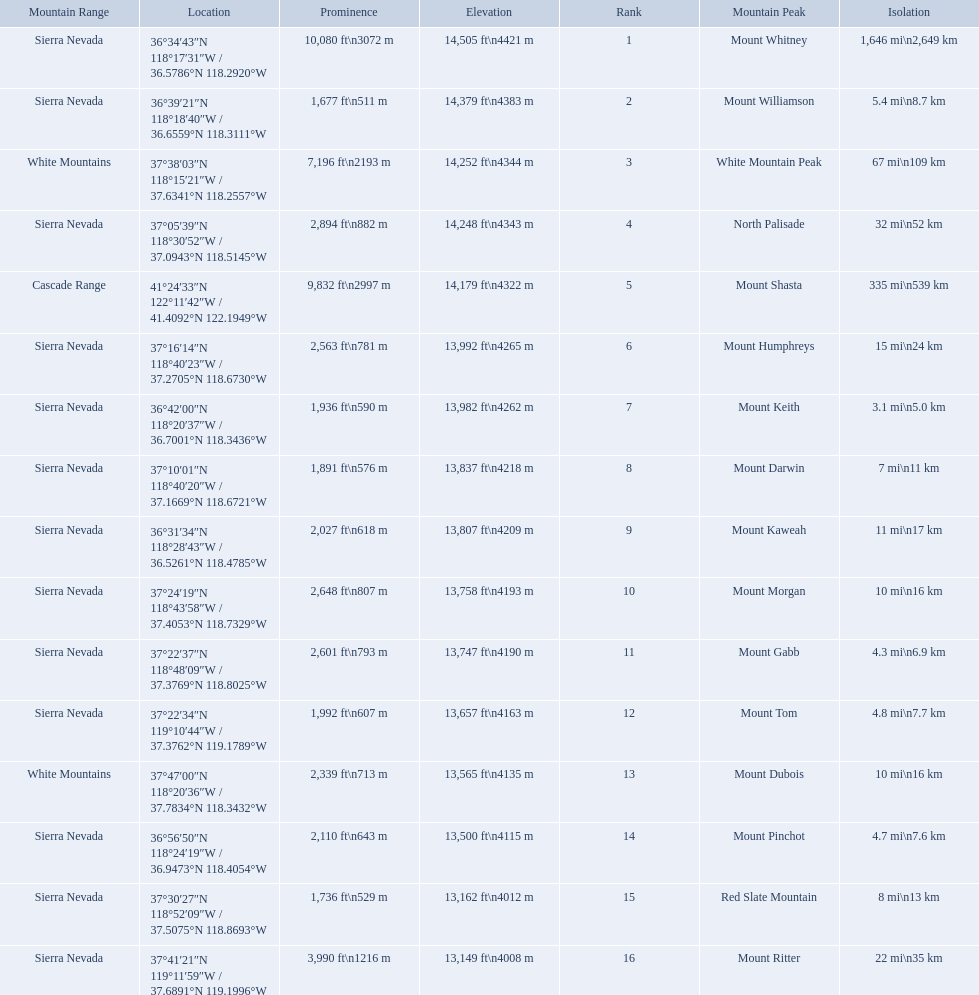Which mountain peaks are lower than 14,000 ft? Mount Humphreys, Mount Keith, Mount Darwin, Mount Kaweah, Mount Morgan, Mount Gabb, Mount Tom, Mount Dubois, Mount Pinchot, Red Slate Mountain, Mount Ritter. Are any of them below 13,500? if so, which ones? Red Slate Mountain, Mount Ritter. What's the lowest peak? 13,149 ft\n4008 m. Which one is that? Mount Ritter. What are all of the mountain peaks? Mount Whitney, Mount Williamson, White Mountain Peak, North Palisade, Mount Shasta, Mount Humphreys, Mount Keith, Mount Darwin, Mount Kaweah, Mount Morgan, Mount Gabb, Mount Tom, Mount Dubois, Mount Pinchot, Red Slate Mountain, Mount Ritter. In what ranges are they located? Sierra Nevada, Sierra Nevada, White Mountains, Sierra Nevada, Cascade Range, Sierra Nevada, Sierra Nevada, Sierra Nevada, Sierra Nevada, Sierra Nevada, Sierra Nevada, Sierra Nevada, White Mountains, Sierra Nevada, Sierra Nevada, Sierra Nevada. And which mountain peak is in the cascade range? Mount Shasta. What are the heights of the californian mountain peaks? 14,505 ft\n4421 m, 14,379 ft\n4383 m, 14,252 ft\n4344 m, 14,248 ft\n4343 m, 14,179 ft\n4322 m, 13,992 ft\n4265 m, 13,982 ft\n4262 m, 13,837 ft\n4218 m, 13,807 ft\n4209 m, 13,758 ft\n4193 m, 13,747 ft\n4190 m, 13,657 ft\n4163 m, 13,565 ft\n4135 m, 13,500 ft\n4115 m, 13,162 ft\n4012 m, 13,149 ft\n4008 m. What elevation is 13,149 ft or less? 13,149 ft\n4008 m. What mountain peak is at this elevation? Mount Ritter. 